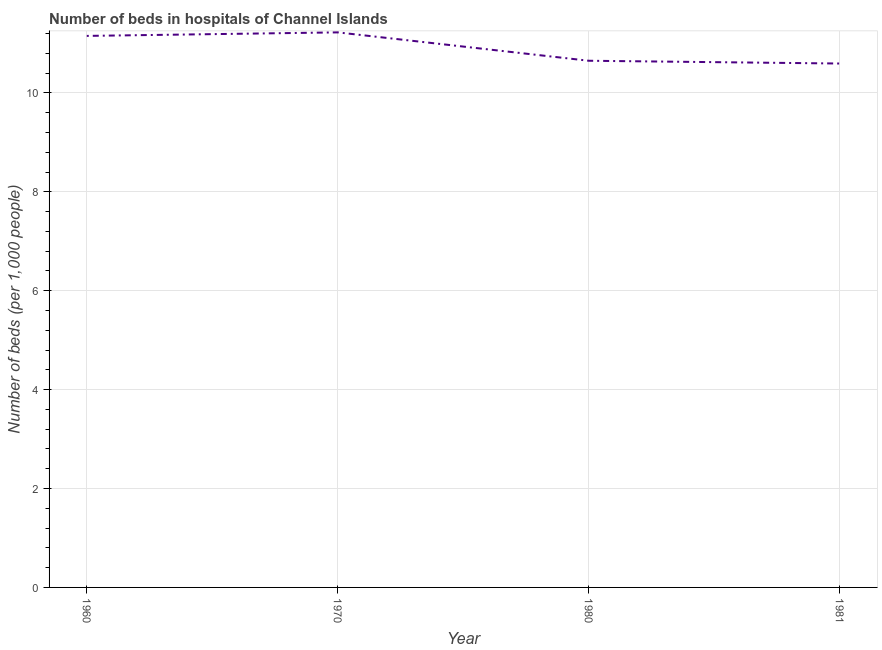What is the number of hospital beds in 1980?
Provide a succinct answer. 10.65. Across all years, what is the maximum number of hospital beds?
Your answer should be compact. 11.23. Across all years, what is the minimum number of hospital beds?
Your answer should be compact. 10.6. What is the sum of the number of hospital beds?
Give a very brief answer. 43.63. What is the difference between the number of hospital beds in 1980 and 1981?
Give a very brief answer. 0.06. What is the average number of hospital beds per year?
Your answer should be very brief. 10.91. What is the median number of hospital beds?
Provide a short and direct response. 10.9. In how many years, is the number of hospital beds greater than 1.2000000000000002 %?
Your response must be concise. 4. Do a majority of the years between 1960 and 1970 (inclusive) have number of hospital beds greater than 4.4 %?
Offer a very short reply. Yes. What is the ratio of the number of hospital beds in 1970 to that in 1980?
Give a very brief answer. 1.05. Is the number of hospital beds in 1970 less than that in 1980?
Your answer should be compact. No. Is the difference between the number of hospital beds in 1960 and 1970 greater than the difference between any two years?
Your response must be concise. No. What is the difference between the highest and the second highest number of hospital beds?
Make the answer very short. 0.07. What is the difference between the highest and the lowest number of hospital beds?
Give a very brief answer. 0.63. In how many years, is the number of hospital beds greater than the average number of hospital beds taken over all years?
Make the answer very short. 2. Does the number of hospital beds monotonically increase over the years?
Ensure brevity in your answer.  No. How many lines are there?
Provide a succinct answer. 1. How many years are there in the graph?
Make the answer very short. 4. Does the graph contain any zero values?
Give a very brief answer. No. Does the graph contain grids?
Provide a succinct answer. Yes. What is the title of the graph?
Make the answer very short. Number of beds in hospitals of Channel Islands. What is the label or title of the Y-axis?
Offer a very short reply. Number of beds (per 1,0 people). What is the Number of beds (per 1,000 people) in 1960?
Give a very brief answer. 11.15. What is the Number of beds (per 1,000 people) in 1970?
Your answer should be compact. 11.23. What is the Number of beds (per 1,000 people) of 1980?
Offer a very short reply. 10.65. What is the Number of beds (per 1,000 people) in 1981?
Provide a short and direct response. 10.6. What is the difference between the Number of beds (per 1,000 people) in 1960 and 1970?
Your answer should be compact. -0.07. What is the difference between the Number of beds (per 1,000 people) in 1960 and 1980?
Keep it short and to the point. 0.5. What is the difference between the Number of beds (per 1,000 people) in 1960 and 1981?
Provide a short and direct response. 0.56. What is the difference between the Number of beds (per 1,000 people) in 1970 and 1980?
Offer a very short reply. 0.57. What is the difference between the Number of beds (per 1,000 people) in 1970 and 1981?
Provide a short and direct response. 0.63. What is the difference between the Number of beds (per 1,000 people) in 1980 and 1981?
Provide a short and direct response. 0.06. What is the ratio of the Number of beds (per 1,000 people) in 1960 to that in 1970?
Give a very brief answer. 0.99. What is the ratio of the Number of beds (per 1,000 people) in 1960 to that in 1980?
Provide a short and direct response. 1.05. What is the ratio of the Number of beds (per 1,000 people) in 1960 to that in 1981?
Give a very brief answer. 1.05. What is the ratio of the Number of beds (per 1,000 people) in 1970 to that in 1980?
Provide a succinct answer. 1.05. What is the ratio of the Number of beds (per 1,000 people) in 1970 to that in 1981?
Provide a succinct answer. 1.06. 